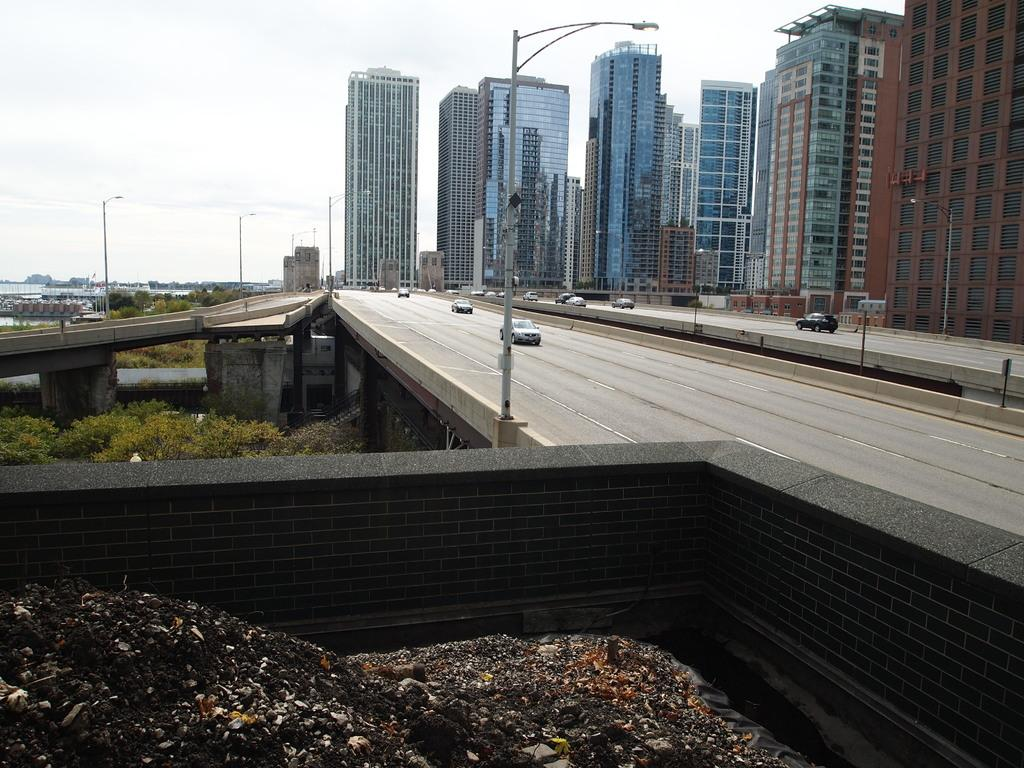What type of structures are visible in the image? There are buildings in the image. What type of transportation infrastructure is present in the image? There is a freeway in the image. What is happening with the vehicles in the image? Vehicles are moving in the image. What type of lighting is present in the image? There are pole lights in the image. What type of vegetation is visible in the image? There are trees in the image. What is the condition of the sky in the image? The sky is cloudy in the image. Can you see a table in the image? There is no table present in the image. What type of tool is being used by the sea in the image? There is no sea or tool present in the image. 